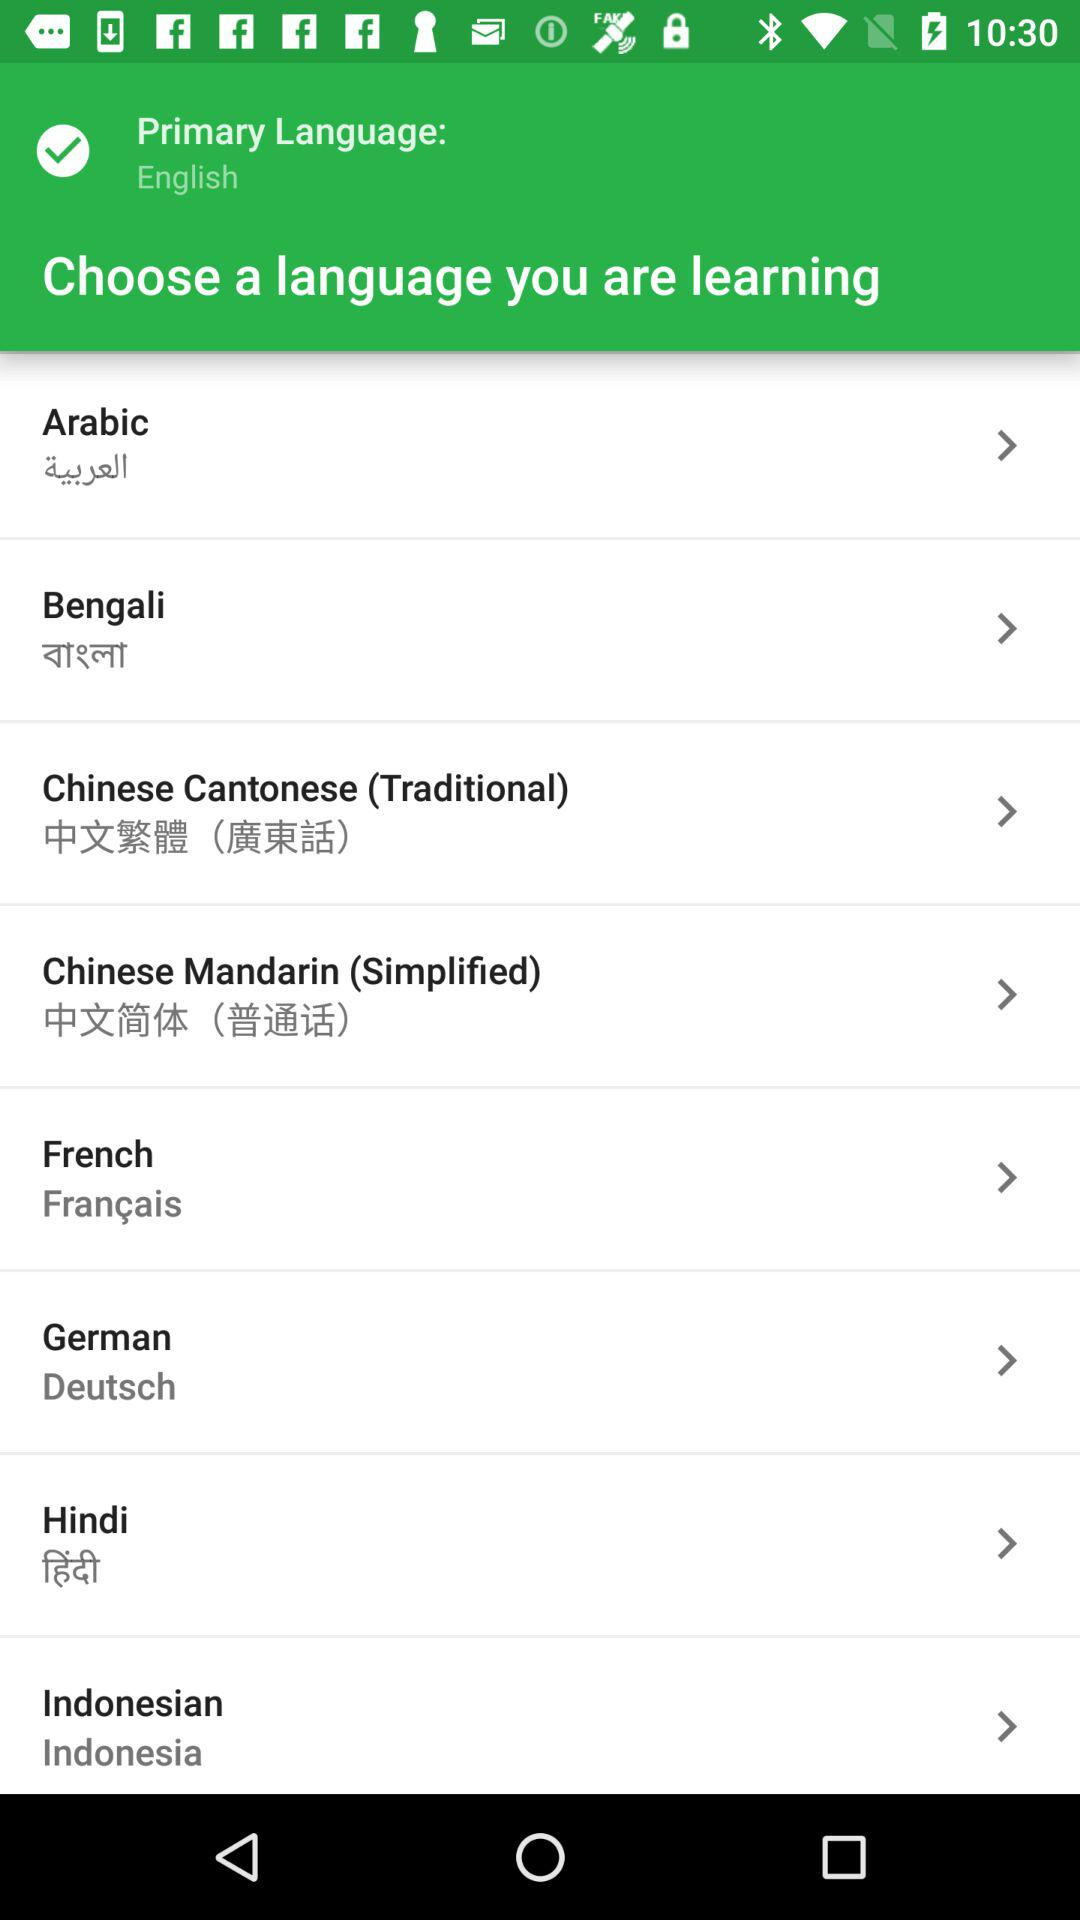What is the primary language? The primary language is English. 